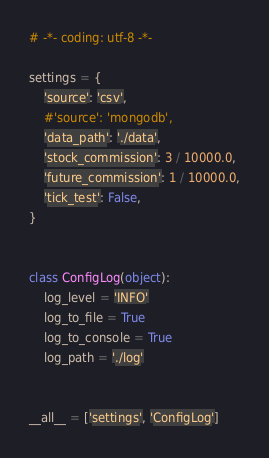<code> <loc_0><loc_0><loc_500><loc_500><_Python_># -*- coding: utf-8 -*-

settings = {
    'source': 'csv',
    #'source': 'mongodb',
    'data_path': './data',
    'stock_commission': 3 / 10000.0,
    'future_commission': 1 / 10000.0,
    'tick_test': False,
}


class ConfigLog(object):
    log_level = 'INFO'
    log_to_file = True
    log_to_console = True
    log_path = './log'
    

__all__ = ['settings', 'ConfigLog']
</code> 